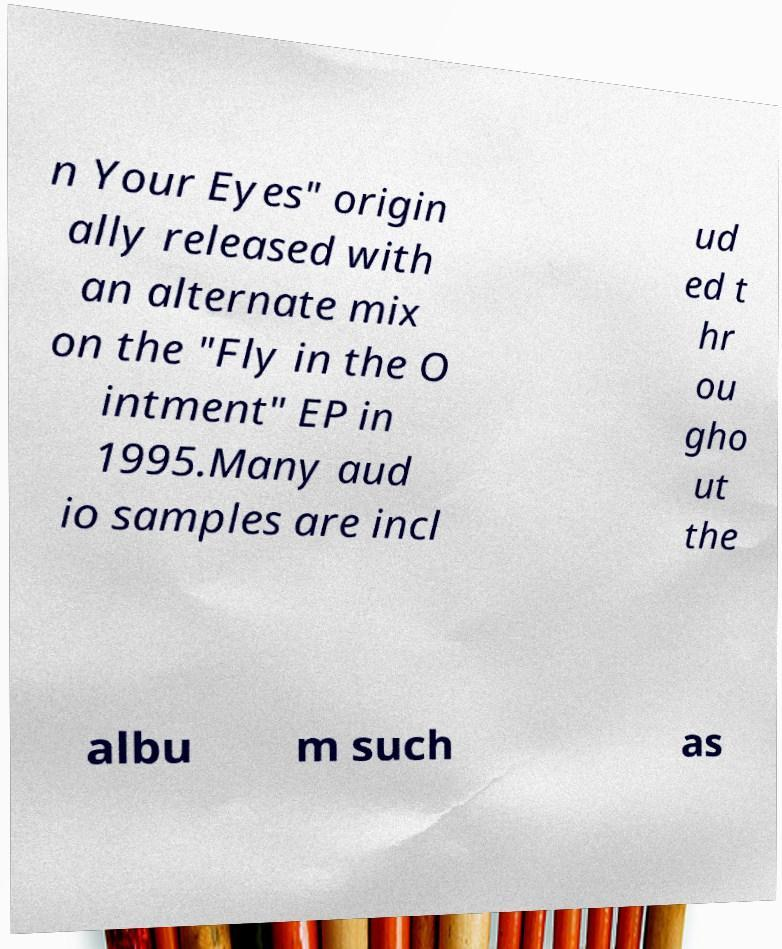Please read and relay the text visible in this image. What does it say? n Your Eyes" origin ally released with an alternate mix on the "Fly in the O intment" EP in 1995.Many aud io samples are incl ud ed t hr ou gho ut the albu m such as 